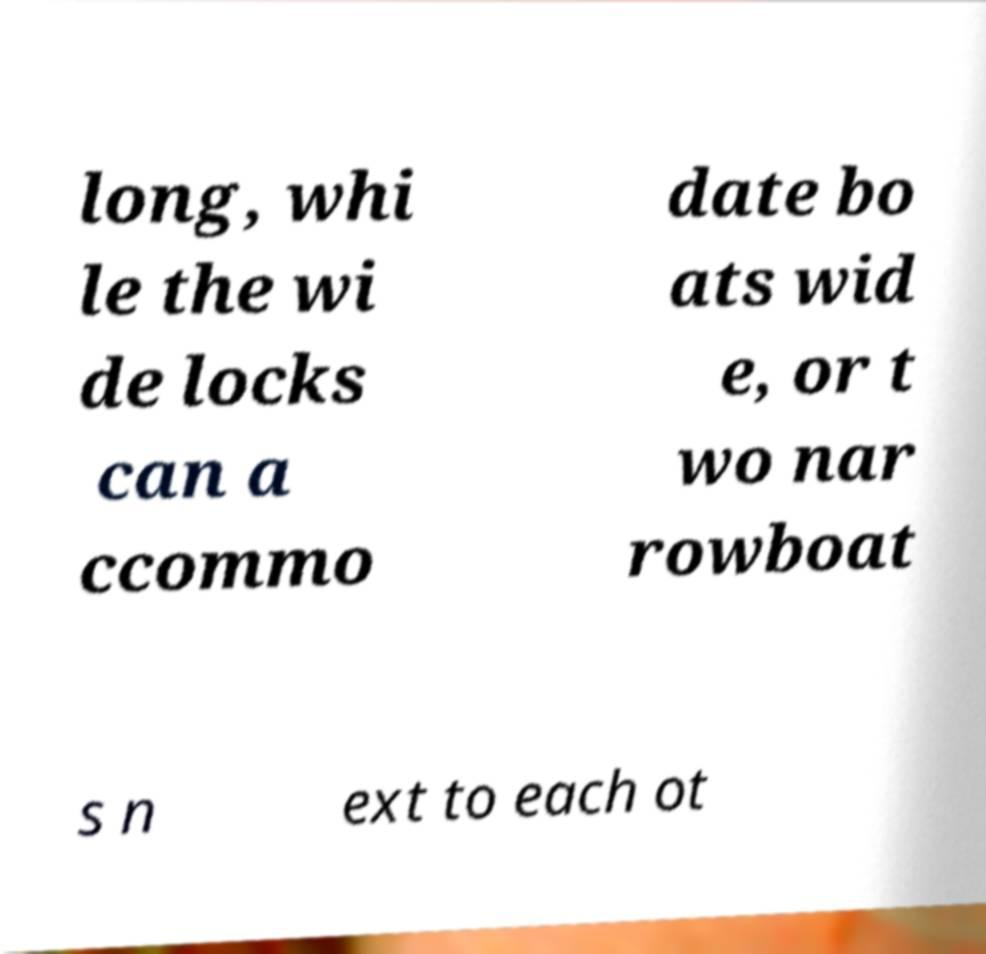What messages or text are displayed in this image? I need them in a readable, typed format. long, whi le the wi de locks can a ccommo date bo ats wid e, or t wo nar rowboat s n ext to each ot 